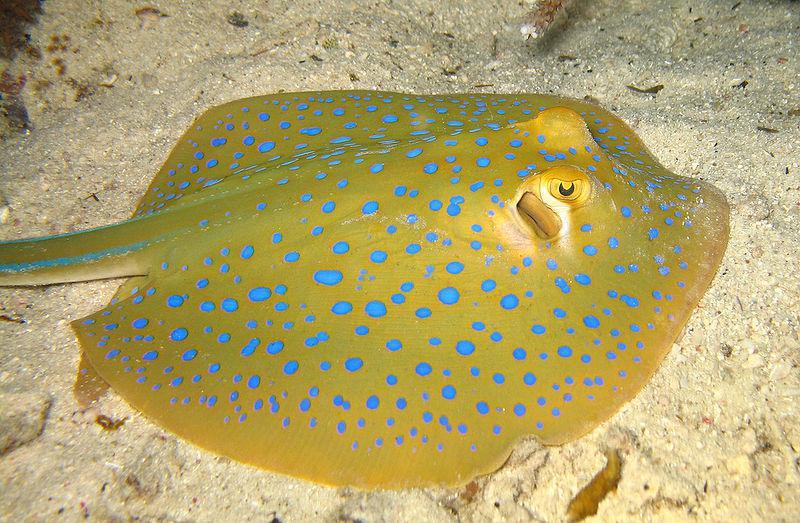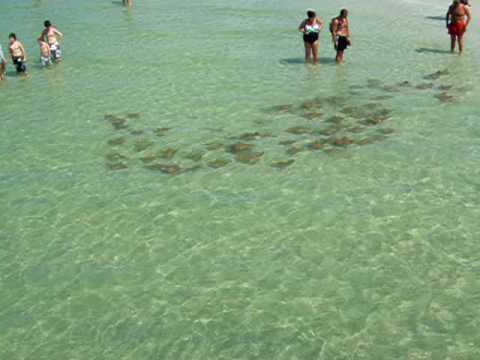The first image is the image on the left, the second image is the image on the right. Examine the images to the left and right. Is the description "An image shows one stingray with spots on its skin." accurate? Answer yes or no. Yes. The first image is the image on the left, the second image is the image on the right. Evaluate the accuracy of this statement regarding the images: "One of the images contains one sting ray with spots.". Is it true? Answer yes or no. Yes. 